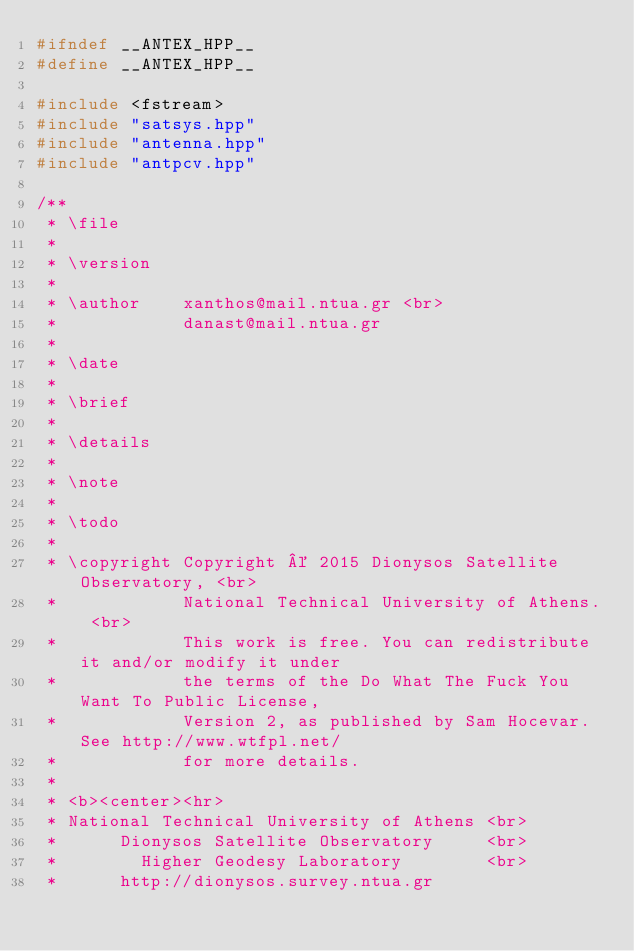Convert code to text. <code><loc_0><loc_0><loc_500><loc_500><_C++_>#ifndef __ANTEX_HPP__
#define __ANTEX_HPP__

#include <fstream>
#include "satsys.hpp"
#include "antenna.hpp"
#include "antpcv.hpp"

/**
 * \file
 *
 * \version
 *
 * \author    xanthos@mail.ntua.gr <br>
 *            danast@mail.ntua.gr
 *
 * \date
 *
 * \brief
 *
 * \details
 *
 * \note
 *
 * \todo
 *
 * \copyright Copyright © 2015 Dionysos Satellite Observatory, <br>
 *            National Technical University of Athens. <br>
 *            This work is free. You can redistribute it and/or modify it under
 *            the terms of the Do What The Fuck You Want To Public License,
 *            Version 2, as published by Sam Hocevar. See http://www.wtfpl.net/
 *            for more details.
 *
 * <b><center><hr>
 * National Technical University of Athens <br>
 *      Dionysos Satellite Observatory     <br>
 *        Higher Geodesy Laboratory        <br>
 *      http://dionysos.survey.ntua.gr</code> 